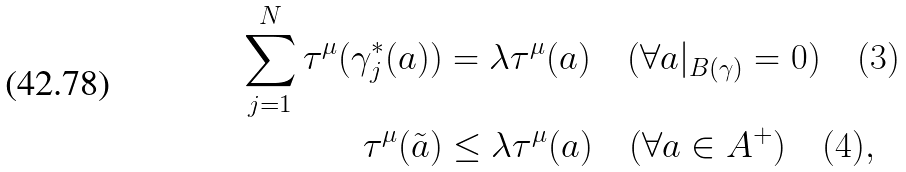Convert formula to latex. <formula><loc_0><loc_0><loc_500><loc_500>\sum _ { j = 1 } ^ { N } \tau ^ { \mu } ( \gamma _ { j } ^ { * } ( a ) ) & = \lambda \tau ^ { \mu } ( a ) \quad ( \forall a | _ { B ( \gamma ) } = 0 ) \quad ( 3 ) \\ \tau ^ { \mu } ( \tilde { a } ) & \leq \lambda \tau ^ { \mu } ( a ) \quad ( \forall a \in A ^ { + } ) \quad ( 4 ) ,</formula> 